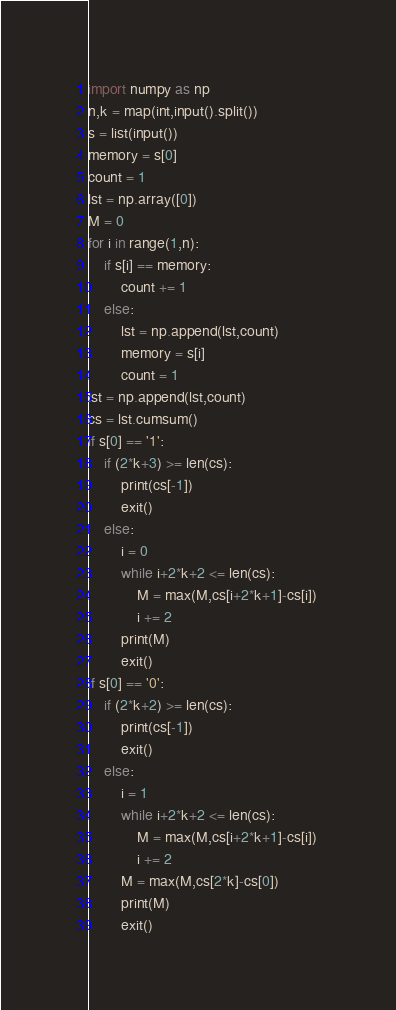Convert code to text. <code><loc_0><loc_0><loc_500><loc_500><_Python_>import numpy as np
n,k = map(int,input().split())
s = list(input())
memory = s[0]
count = 1
lst = np.array([0])
M = 0
for i in range(1,n):
    if s[i] == memory:
        count += 1
    else:
        lst = np.append(lst,count)
        memory = s[i]
        count = 1
lst = np.append(lst,count)
cs = lst.cumsum()
if s[0] == '1':
    if (2*k+3) >= len(cs):
        print(cs[-1])
        exit()
    else:
        i = 0
        while i+2*k+2 <= len(cs):           
            M = max(M,cs[i+2*k+1]-cs[i])
            i += 2
        print(M)
        exit()
if s[0] == '0':
    if (2*k+2) >= len(cs):
        print(cs[-1])
        exit()
    else:
        i = 1
        while i+2*k+2 <= len(cs):
            M = max(M,cs[i+2*k+1]-cs[i])
            i += 2
        M = max(M,cs[2*k]-cs[0])
        print(M)
        exit()
</code> 